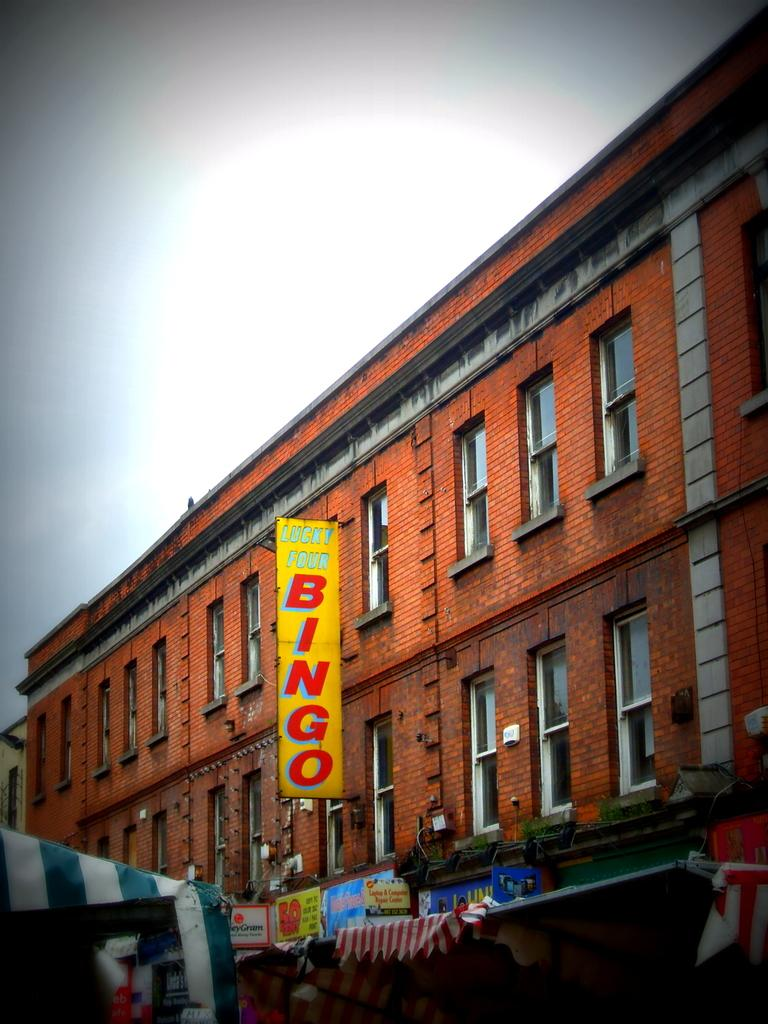What type of structure is present in the image? There is a building in the image. What is written on the boards attached to the building? The building has boards with text written on them. What additional feature can be seen in the image? There is a tent in the image. What can be used to illuminate the area in the image? There are lights in the image. What are the windows on the building used for? The building has windows, which are typically used for letting in light and providing a view of the outside. What is visible at the top of the image? The sky is visible at the top of the image. What type of creature is guiding the error in the image? There is no creature or error present in the image. 